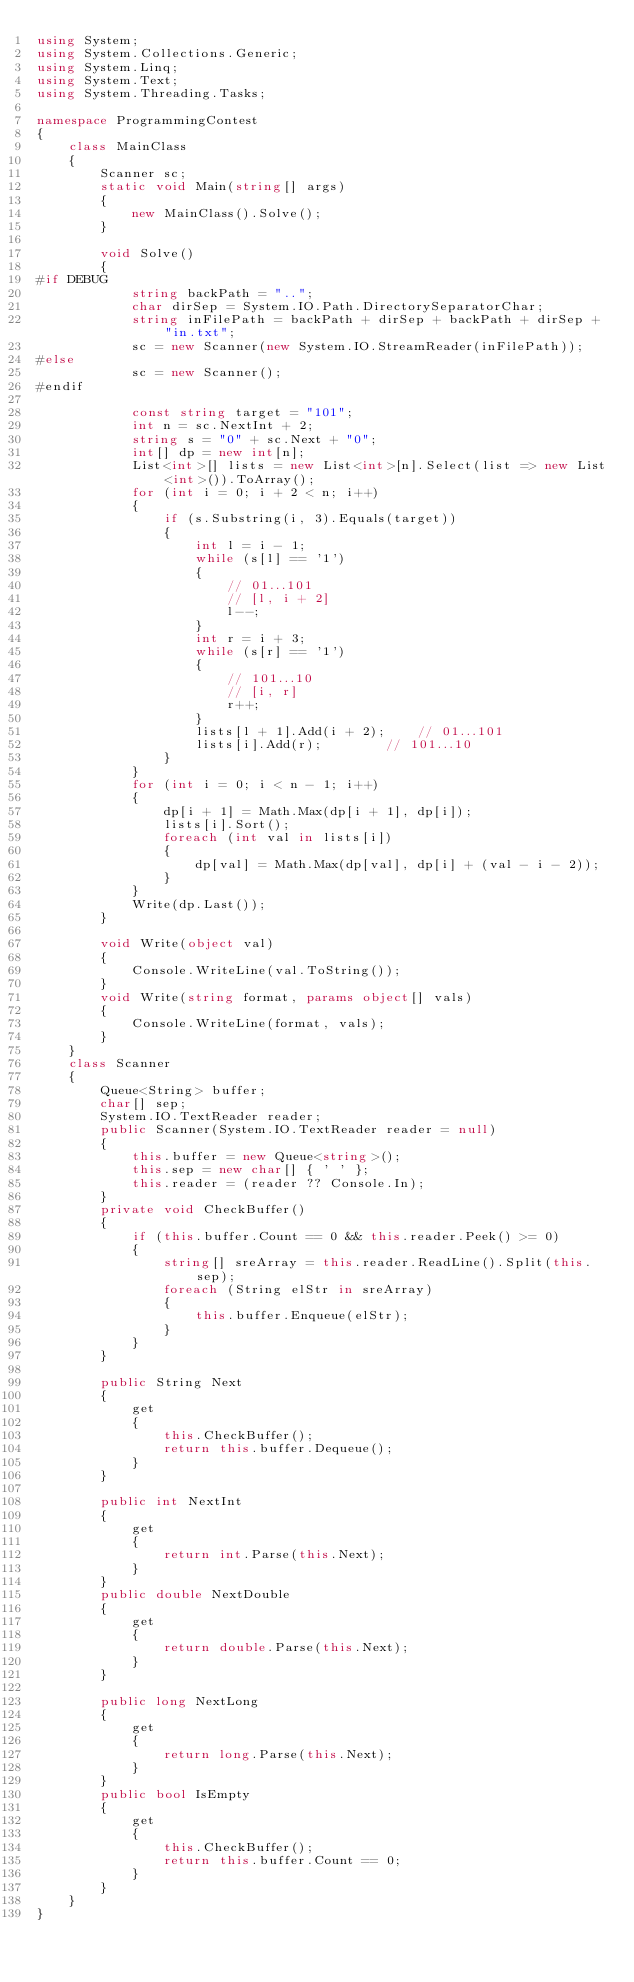Convert code to text. <code><loc_0><loc_0><loc_500><loc_500><_C#_>using System;
using System.Collections.Generic;
using System.Linq;
using System.Text;
using System.Threading.Tasks;

namespace ProgrammingContest
{
    class MainClass
    {
        Scanner sc;
        static void Main(string[] args)
        {
            new MainClass().Solve();
        }

        void Solve()
        {
#if DEBUG
            string backPath = "..";
            char dirSep = System.IO.Path.DirectorySeparatorChar;
            string inFilePath = backPath + dirSep + backPath + dirSep + "in.txt";
            sc = new Scanner(new System.IO.StreamReader(inFilePath));
#else
            sc = new Scanner();
#endif

            const string target = "101";
            int n = sc.NextInt + 2;
            string s = "0" + sc.Next + "0";
            int[] dp = new int[n];
            List<int>[] lists = new List<int>[n].Select(list => new List<int>()).ToArray();
            for (int i = 0; i + 2 < n; i++)
            {
                if (s.Substring(i, 3).Equals(target))
                {
                    int l = i - 1;
                    while (s[l] == '1')
                    {
                        // 01...101
                        // [l, i + 2]
                        l--;
                    }
                    int r = i + 3;
                    while (s[r] == '1')
                    {
                        // 101...10
                        // [i, r]
                        r++;
                    }
                    lists[l + 1].Add(i + 2);    // 01...101
                    lists[i].Add(r);        // 101...10
                }
            }
            for (int i = 0; i < n - 1; i++)
            {
                dp[i + 1] = Math.Max(dp[i + 1], dp[i]);
                lists[i].Sort();
                foreach (int val in lists[i])
                {
                    dp[val] = Math.Max(dp[val], dp[i] + (val - i - 2)); 
                }
            }
            Write(dp.Last());
        }

        void Write(object val)
        {
            Console.WriteLine(val.ToString());
        }
        void Write(string format, params object[] vals)
        {
            Console.WriteLine(format, vals);
        }
    }
    class Scanner
    {
        Queue<String> buffer;
        char[] sep;
        System.IO.TextReader reader;
        public Scanner(System.IO.TextReader reader = null)
        {
            this.buffer = new Queue<string>();
            this.sep = new char[] { ' ' };
            this.reader = (reader ?? Console.In);
        }
        private void CheckBuffer()
        {
            if (this.buffer.Count == 0 && this.reader.Peek() >= 0)
            {
                string[] sreArray = this.reader.ReadLine().Split(this.sep);
                foreach (String elStr in sreArray)
                {
                    this.buffer.Enqueue(elStr);
                }
            }
        }

        public String Next
        {
            get
            {
                this.CheckBuffer();
                return this.buffer.Dequeue();
            }
        }

        public int NextInt
        {
            get
            {
                return int.Parse(this.Next);
            }
        }
        public double NextDouble
        {
            get
            {
                return double.Parse(this.Next);
            }
        }

        public long NextLong
        {
            get
            {
                return long.Parse(this.Next);
            }
        }
        public bool IsEmpty
        {
            get
            {
                this.CheckBuffer();
                return this.buffer.Count == 0;
            }
        }
    }
}
</code> 